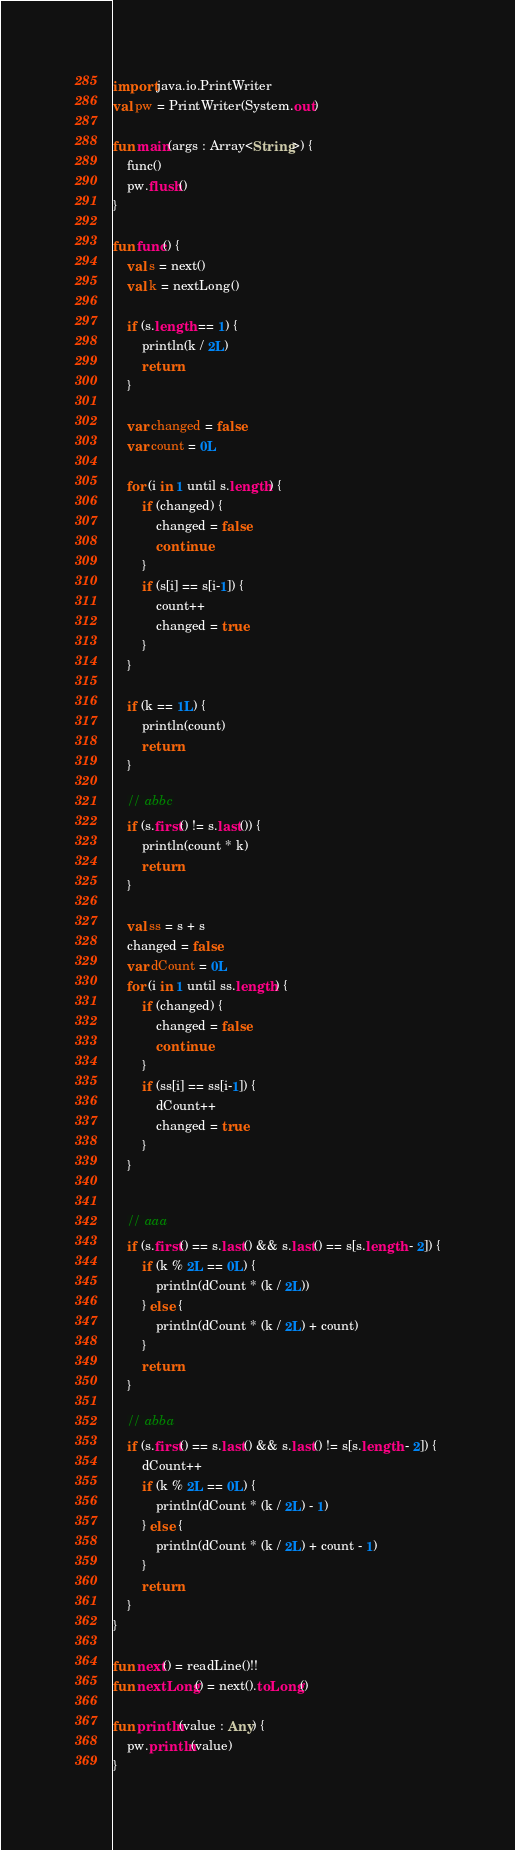Convert code to text. <code><loc_0><loc_0><loc_500><loc_500><_Kotlin_>import java.io.PrintWriter
val pw = PrintWriter(System.out)

fun main(args : Array<String>) {
    func()
    pw.flush()
}

fun func() {
    val s = next()
    val k = nextLong()

    if (s.length == 1) {
        println(k / 2L)
        return
    }

    var changed = false
    var count = 0L

    for (i in 1 until s.length) {
        if (changed) {
            changed = false
            continue
        }
        if (s[i] == s[i-1]) {
            count++
            changed = true
        }
    }

    if (k == 1L) {
        println(count)
        return
    }

    // abbc
    if (s.first() != s.last()) {
        println(count * k)
        return
    }

    val ss = s + s
    changed = false
    var dCount = 0L
    for (i in 1 until ss.length) {
        if (changed) {
            changed = false
            continue
        }
        if (ss[i] == ss[i-1]) {
            dCount++
            changed = true
        }
    }


    // aaa
    if (s.first() == s.last() && s.last() == s[s.length - 2]) {
        if (k % 2L == 0L) {
            println(dCount * (k / 2L))
        } else {
            println(dCount * (k / 2L) + count)
        }
        return
    }

    // abba
    if (s.first() == s.last() && s.last() != s[s.length - 2]) {
        dCount++
        if (k % 2L == 0L) {
            println(dCount * (k / 2L) - 1)
        } else {
            println(dCount * (k / 2L) + count - 1)
        }
        return
    }
}

fun next() = readLine()!!
fun nextLong() = next().toLong()

fun println(value : Any) {
    pw.println(value)
}
</code> 